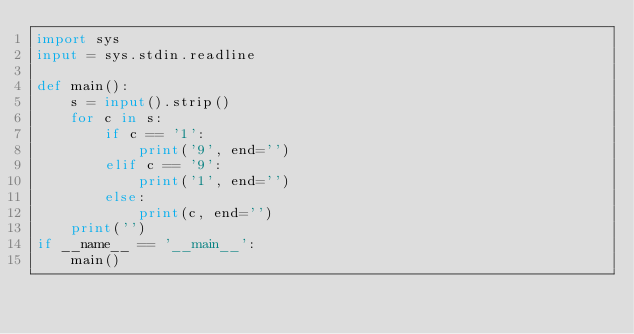<code> <loc_0><loc_0><loc_500><loc_500><_Python_>import sys
input = sys.stdin.readline

def main():
	s = input().strip()
	for c in s:
		if c == '1':
			print('9', end='')
		elif c == '9':
			print('1', end='')
		else:
			print(c, end='')
	print('')
if __name__ == '__main__':
	main()
</code> 